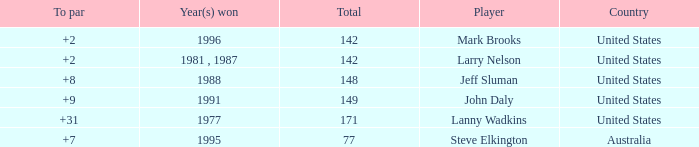Name the Total of australia and a To par smaller than 7? None. 